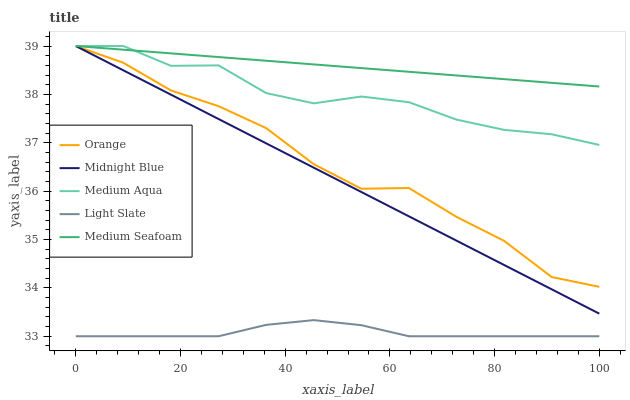Does Light Slate have the minimum area under the curve?
Answer yes or no. Yes. Does Medium Seafoam have the maximum area under the curve?
Answer yes or no. Yes. Does Medium Aqua have the minimum area under the curve?
Answer yes or no. No. Does Medium Aqua have the maximum area under the curve?
Answer yes or no. No. Is Medium Seafoam the smoothest?
Answer yes or no. Yes. Is Orange the roughest?
Answer yes or no. Yes. Is Light Slate the smoothest?
Answer yes or no. No. Is Light Slate the roughest?
Answer yes or no. No. Does Light Slate have the lowest value?
Answer yes or no. Yes. Does Medium Aqua have the lowest value?
Answer yes or no. No. Does Medium Seafoam have the highest value?
Answer yes or no. Yes. Does Light Slate have the highest value?
Answer yes or no. No. Is Light Slate less than Orange?
Answer yes or no. Yes. Is Midnight Blue greater than Light Slate?
Answer yes or no. Yes. Does Orange intersect Midnight Blue?
Answer yes or no. Yes. Is Orange less than Midnight Blue?
Answer yes or no. No. Is Orange greater than Midnight Blue?
Answer yes or no. No. Does Light Slate intersect Orange?
Answer yes or no. No. 